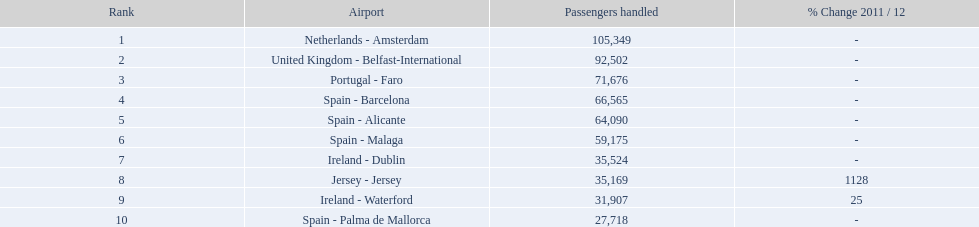What are all of the destinations out of the london southend airport? Netherlands - Amsterdam, United Kingdom - Belfast-International, Portugal - Faro, Spain - Barcelona, Spain - Alicante, Spain - Malaga, Ireland - Dublin, Jersey - Jersey, Ireland - Waterford, Spain - Palma de Mallorca. How many passengers has each destination handled? 105,349, 92,502, 71,676, 66,565, 64,090, 59,175, 35,524, 35,169, 31,907, 27,718. And of those, which airport handled the fewest passengers? Spain - Palma de Mallorca. What are all the airports in the top 10 most crowded routes to and from london southend airport? Netherlands - Amsterdam, United Kingdom - Belfast-International, Portugal - Faro, Spain - Barcelona, Spain - Alicante, Spain - Malaga, Ireland - Dublin, Jersey - Jersey, Ireland - Waterford, Spain - Palma de Mallorca. Which airports are situated in portugal? Portugal - Faro. 